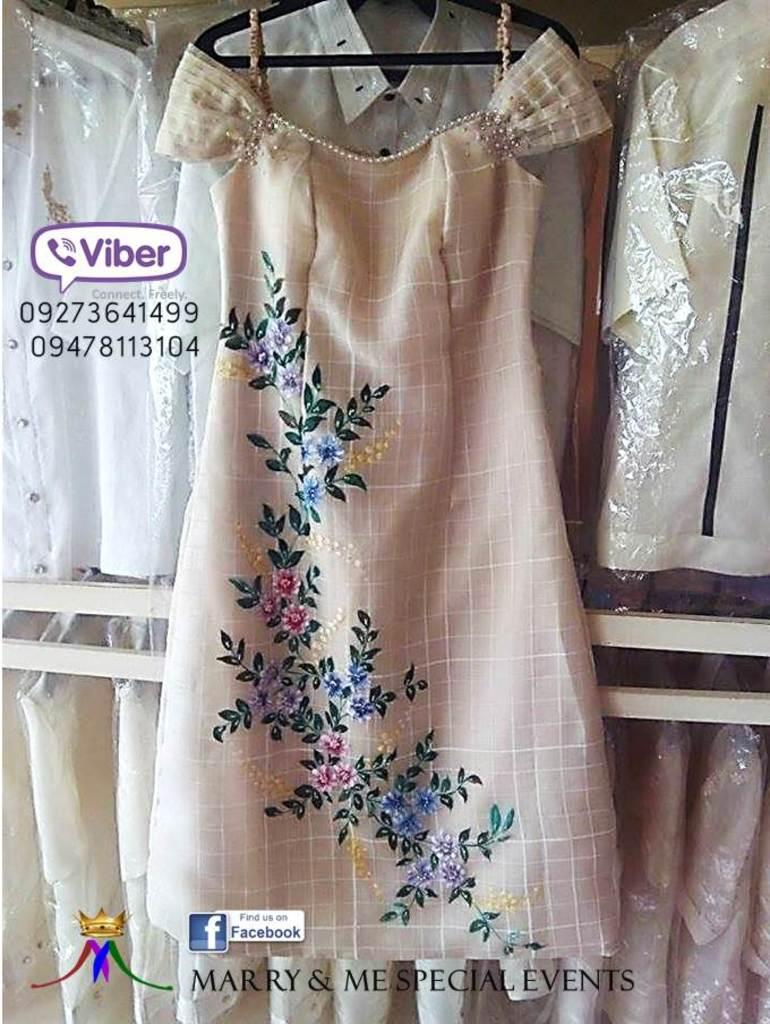What is the main subject of the image? The main subject of the image is a pamphlet. What is featured on the pamphlet? The pamphlet features a peach-colored dress. Can you describe any other clothing items visible in the image? There are other shirts visible in the background of the image. What type of frame is surrounding the pamphlet in the image? There is no frame surrounding the pamphlet in the image. What is the person holding the pamphlet reading in the image? The image does not show a person holding or reading the pamphlet. 